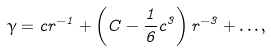Convert formula to latex. <formula><loc_0><loc_0><loc_500><loc_500>\gamma = c r ^ { - 1 } + \left ( C - \frac { 1 } { 6 } c ^ { 3 } \right ) r ^ { - 3 } + \dots ,</formula> 